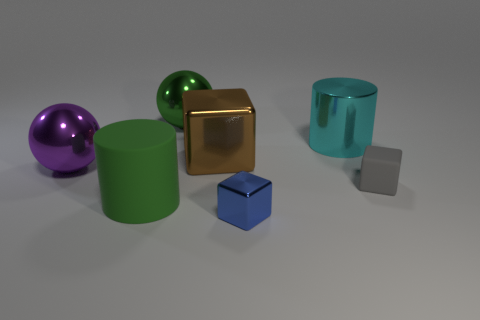Add 3 tiny objects. How many objects exist? 10 Subtract all cylinders. How many objects are left? 5 Subtract 0 blue cylinders. How many objects are left? 7 Subtract all cyan shiny objects. Subtract all large cylinders. How many objects are left? 4 Add 5 big purple balls. How many big purple balls are left? 6 Add 4 small blue metal things. How many small blue metal things exist? 5 